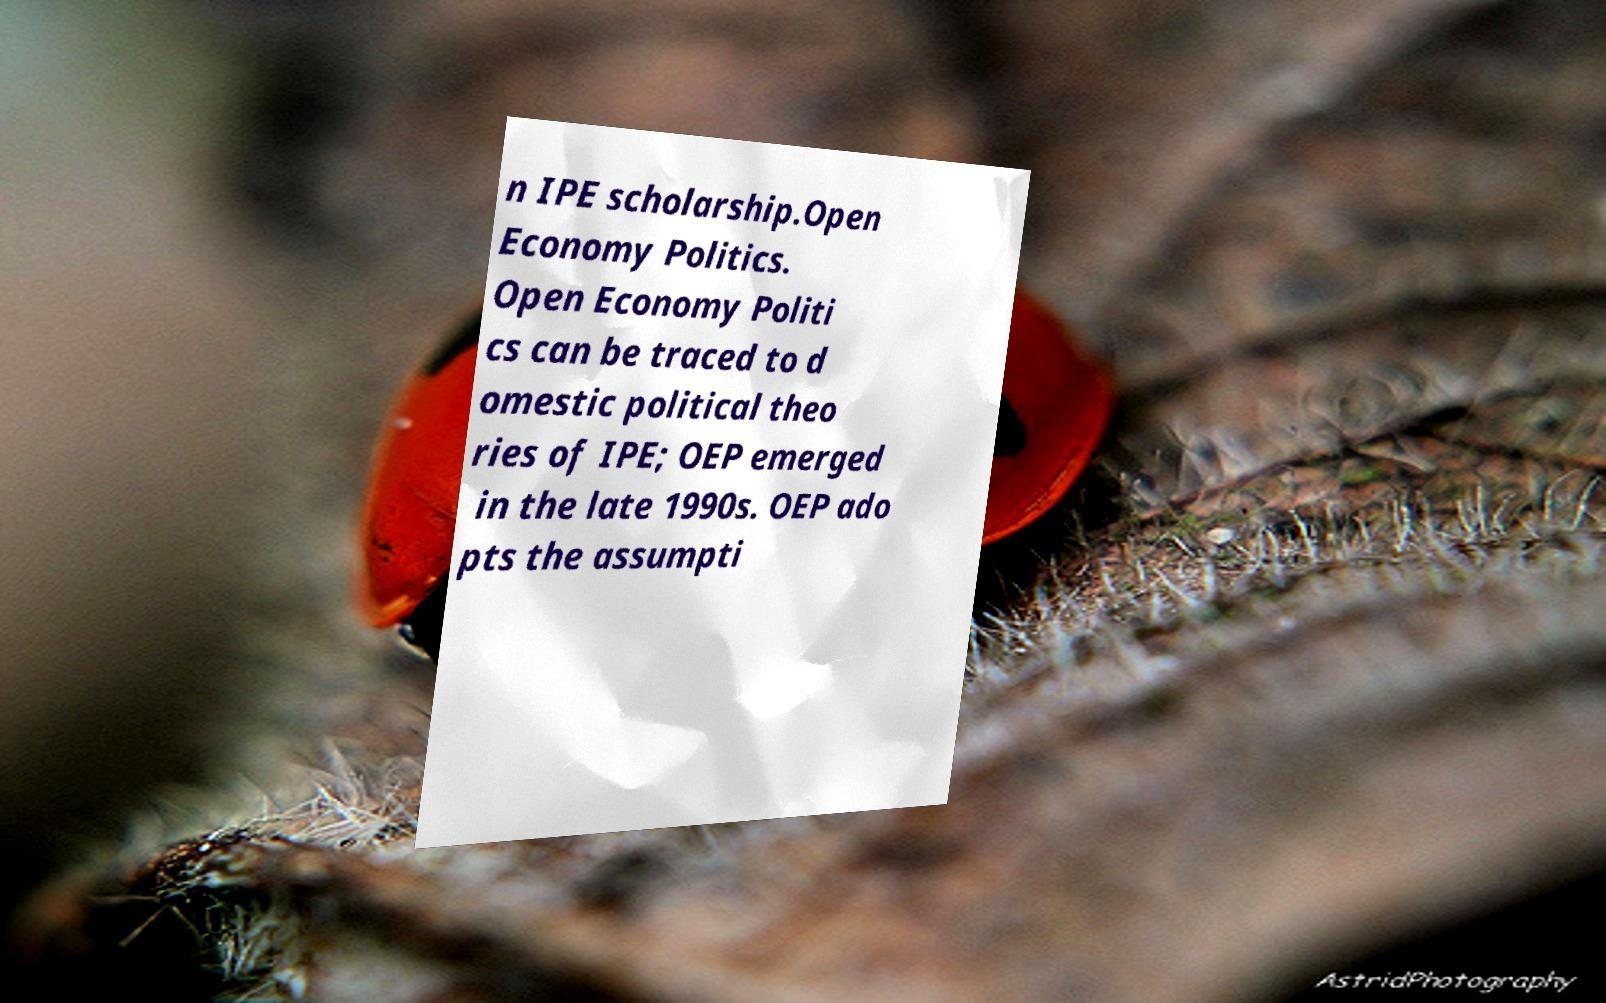There's text embedded in this image that I need extracted. Can you transcribe it verbatim? n IPE scholarship.Open Economy Politics. Open Economy Politi cs can be traced to d omestic political theo ries of IPE; OEP emerged in the late 1990s. OEP ado pts the assumpti 